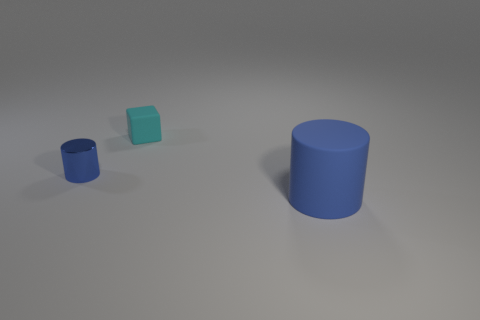What number of tiny blue cylinders are the same material as the tiny cyan cube?
Give a very brief answer. 0. Does the rubber object that is to the left of the large blue rubber object have the same shape as the large blue matte thing in front of the small rubber object?
Provide a short and direct response. No. What color is the rubber object that is left of the blue matte cylinder?
Make the answer very short. Cyan. Are there any other objects that have the same shape as the blue metallic object?
Your answer should be very brief. Yes. What is the material of the small block?
Make the answer very short. Rubber. What is the size of the thing that is in front of the cyan matte block and to the right of the small cylinder?
Ensure brevity in your answer.  Large. There is a tiny cylinder that is the same color as the large cylinder; what material is it?
Offer a terse response. Metal. What number of tiny gray objects are there?
Offer a terse response. 0. Is the number of large gray cylinders less than the number of small metallic cylinders?
Ensure brevity in your answer.  Yes. There is a cyan object that is the same size as the blue metallic thing; what is it made of?
Provide a succinct answer. Rubber. 